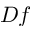Convert formula to latex. <formula><loc_0><loc_0><loc_500><loc_500>D f</formula> 